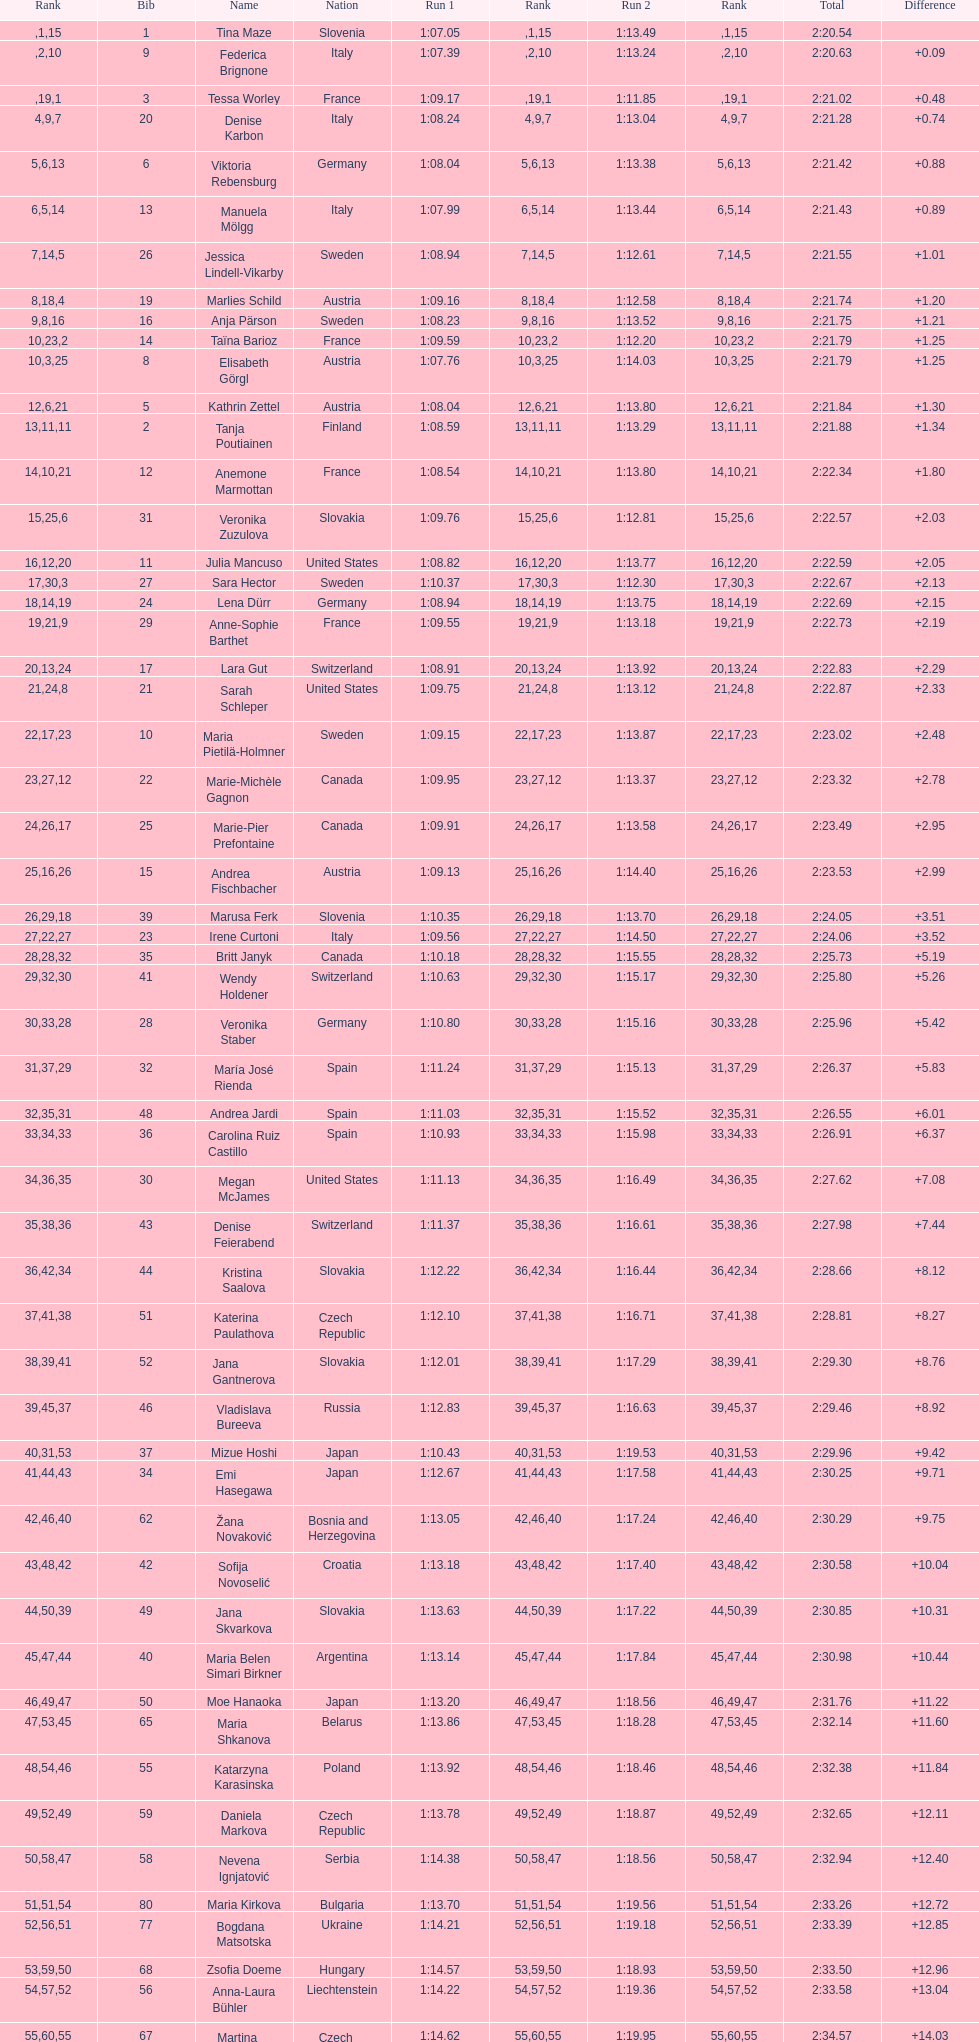How many total names are there? 116. 